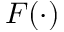<formula> <loc_0><loc_0><loc_500><loc_500>F ( \cdot )</formula> 